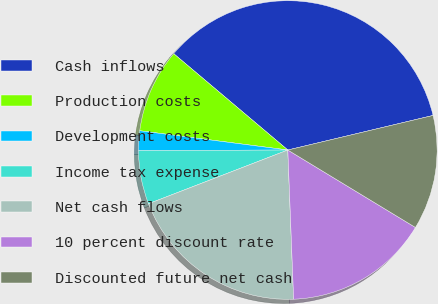Convert chart. <chart><loc_0><loc_0><loc_500><loc_500><pie_chart><fcel>Cash inflows<fcel>Production costs<fcel>Development costs<fcel>Income tax expense<fcel>Net cash flows<fcel>10 percent discount rate<fcel>Discounted future net cash<nl><fcel>35.12%<fcel>9.1%<fcel>2.12%<fcel>5.8%<fcel>19.76%<fcel>15.7%<fcel>12.4%<nl></chart> 